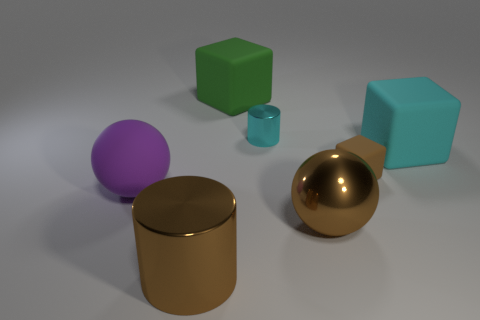Add 1 cubes. How many objects exist? 8 Subtract all large blocks. How many blocks are left? 1 Subtract all brown blocks. How many blocks are left? 2 Subtract 3 cubes. How many cubes are left? 0 Subtract all cubes. How many objects are left? 4 Subtract all large rubber objects. Subtract all large purple rubber blocks. How many objects are left? 4 Add 1 cyan matte blocks. How many cyan matte blocks are left? 2 Add 3 tiny cubes. How many tiny cubes exist? 4 Subtract 1 brown cylinders. How many objects are left? 6 Subtract all green cylinders. Subtract all cyan blocks. How many cylinders are left? 2 